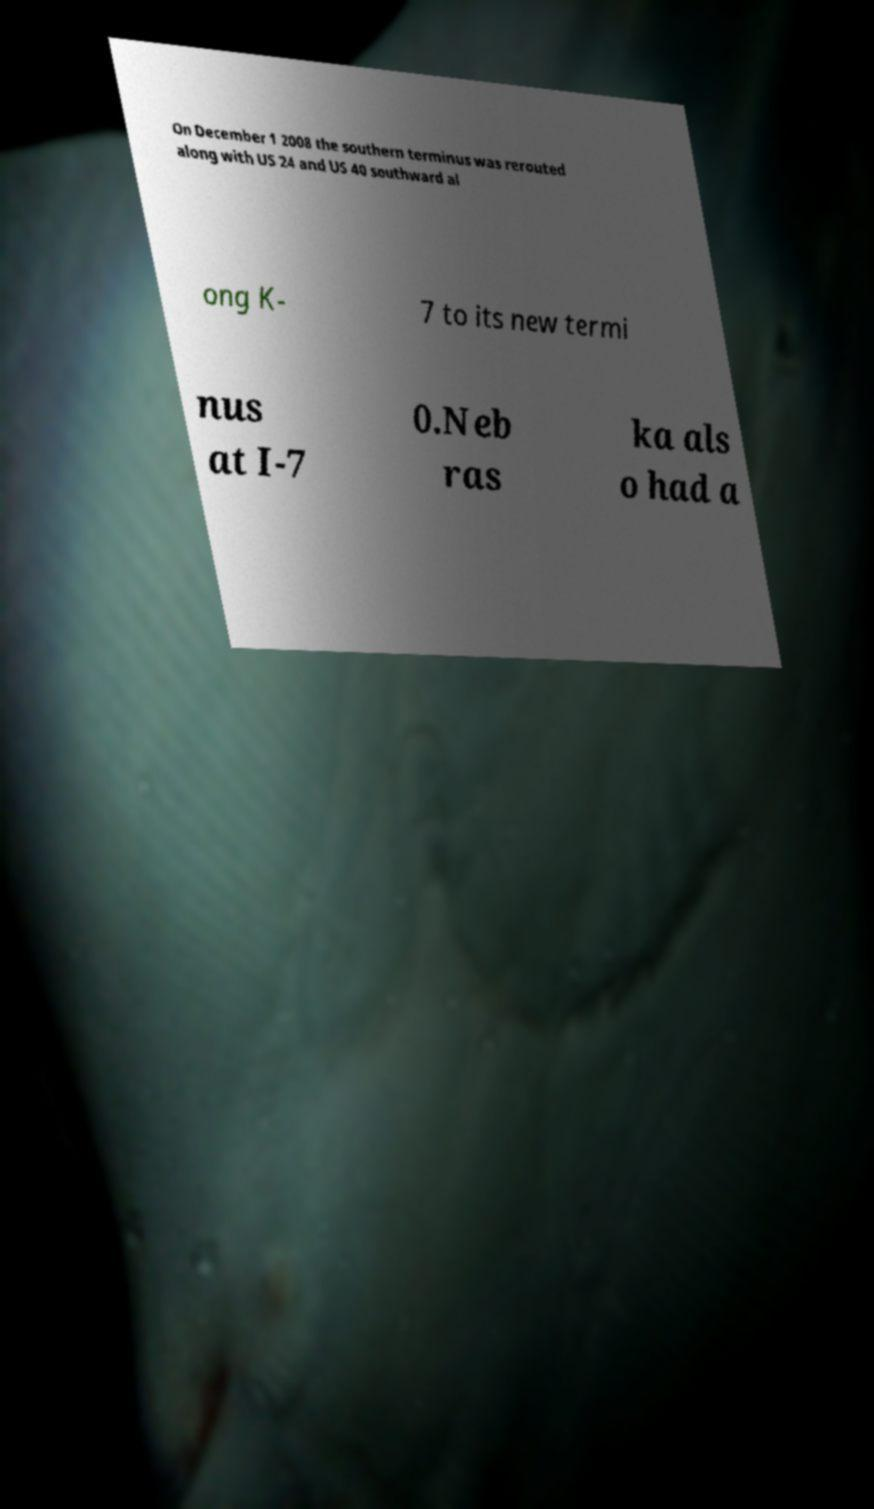Could you extract and type out the text from this image? On December 1 2008 the southern terminus was rerouted along with US 24 and US 40 southward al ong K- 7 to its new termi nus at I-7 0.Neb ras ka als o had a 